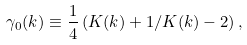Convert formula to latex. <formula><loc_0><loc_0><loc_500><loc_500>\gamma _ { 0 } ( k ) \equiv \frac { 1 } { 4 } \left ( K ( k ) + 1 / K ( k ) - 2 \right ) ,</formula> 